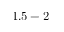Convert formula to latex. <formula><loc_0><loc_0><loc_500><loc_500>1 . 5 - 2</formula> 